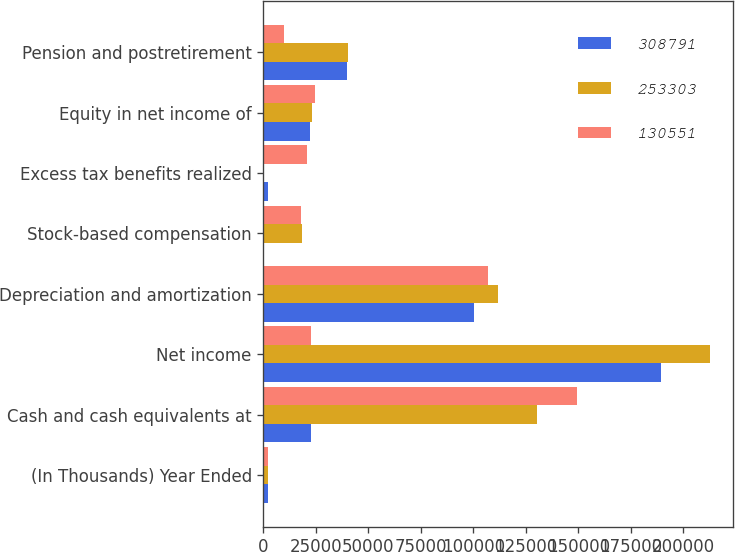Convert chart. <chart><loc_0><loc_0><loc_500><loc_500><stacked_bar_chart><ecel><fcel>(In Thousands) Year Ended<fcel>Cash and cash equivalents at<fcel>Net income<fcel>Depreciation and amortization<fcel>Stock-based compensation<fcel>Excess tax benefits realized<fcel>Equity in net income of<fcel>Pension and postretirement<nl><fcel>308791<fcel>2009<fcel>22724<fcel>189623<fcel>100513<fcel>307<fcel>2111<fcel>22322<fcel>39700<nl><fcel>253303<fcel>2008<fcel>130551<fcel>213008<fcel>111685<fcel>18467<fcel>372<fcel>23126<fcel>40279<nl><fcel>130551<fcel>2007<fcel>149499<fcel>22724<fcel>106855<fcel>18110<fcel>20659<fcel>24581<fcel>9953<nl></chart> 